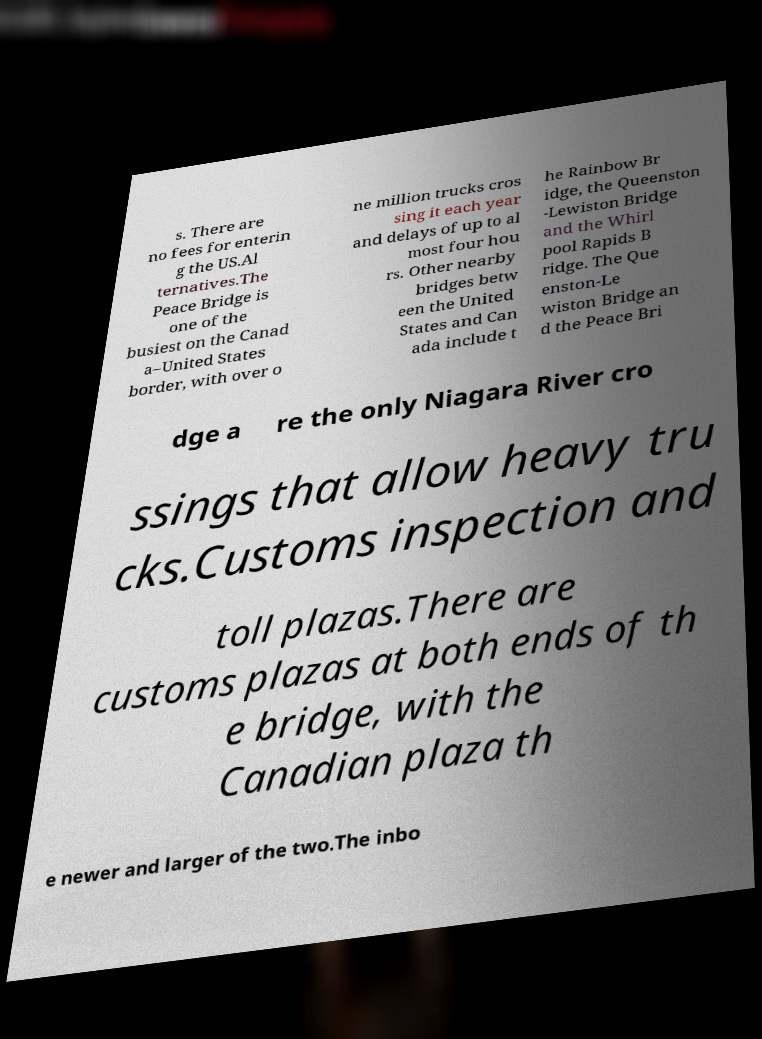There's text embedded in this image that I need extracted. Can you transcribe it verbatim? s. There are no fees for enterin g the US.Al ternatives.The Peace Bridge is one of the busiest on the Canad a–United States border, with over o ne million trucks cros sing it each year and delays of up to al most four hou rs. Other nearby bridges betw een the United States and Can ada include t he Rainbow Br idge, the Queenston -Lewiston Bridge and the Whirl pool Rapids B ridge. The Que enston-Le wiston Bridge an d the Peace Bri dge a re the only Niagara River cro ssings that allow heavy tru cks.Customs inspection and toll plazas.There are customs plazas at both ends of th e bridge, with the Canadian plaza th e newer and larger of the two.The inbo 